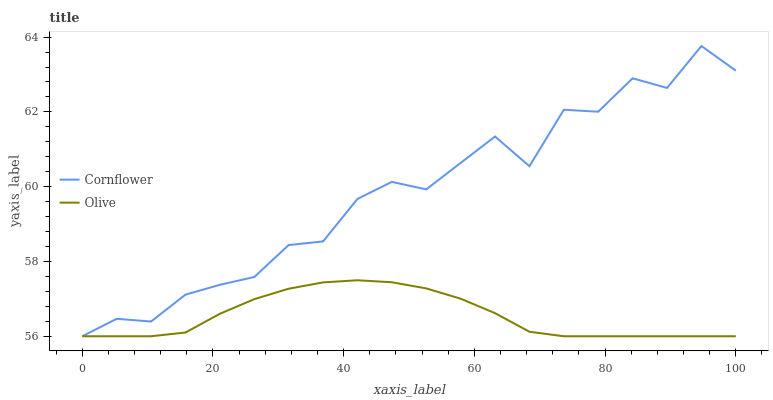Does Olive have the minimum area under the curve?
Answer yes or no. Yes. Does Cornflower have the maximum area under the curve?
Answer yes or no. Yes. Does Cornflower have the minimum area under the curve?
Answer yes or no. No. Is Olive the smoothest?
Answer yes or no. Yes. Is Cornflower the roughest?
Answer yes or no. Yes. Is Cornflower the smoothest?
Answer yes or no. No. 